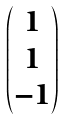<formula> <loc_0><loc_0><loc_500><loc_500>\begin{pmatrix} 1 \\ 1 \\ - 1 \end{pmatrix}</formula> 